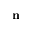<formula> <loc_0><loc_0><loc_500><loc_500>{ n }</formula> 